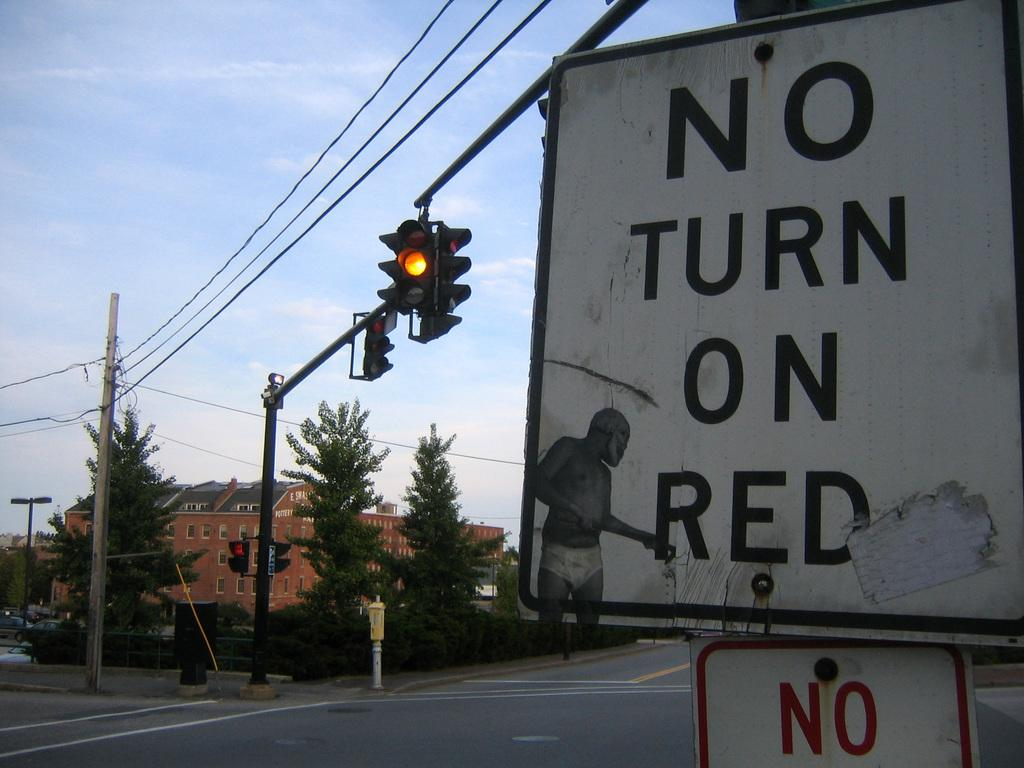Provide a one-sentence caption for the provided image. A yellow light with a sign that states no turn on red. 